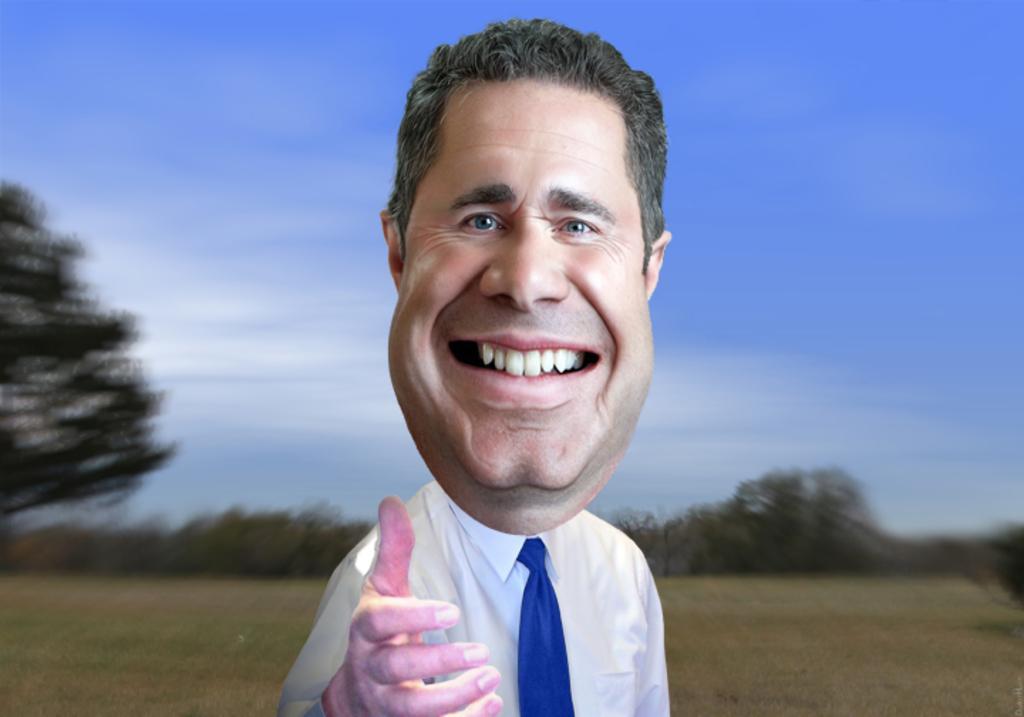How would you summarize this image in a sentence or two? In front of the image there is a depiction of a person having a smile on his face. At the bottom of the image there is grass on the surface. In the background of the image there are trees. At the top of the image there is sky. 